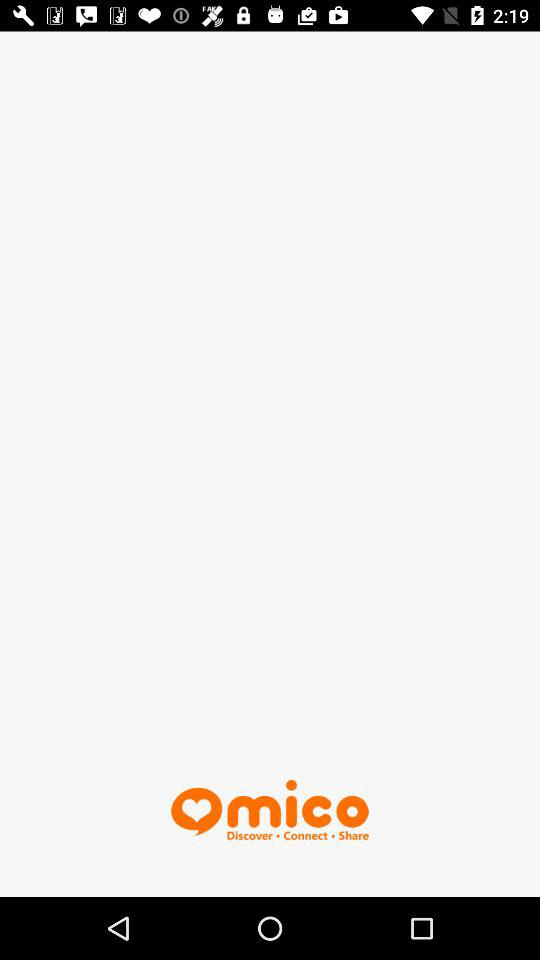What is the name of the application? The application name is "mico". 